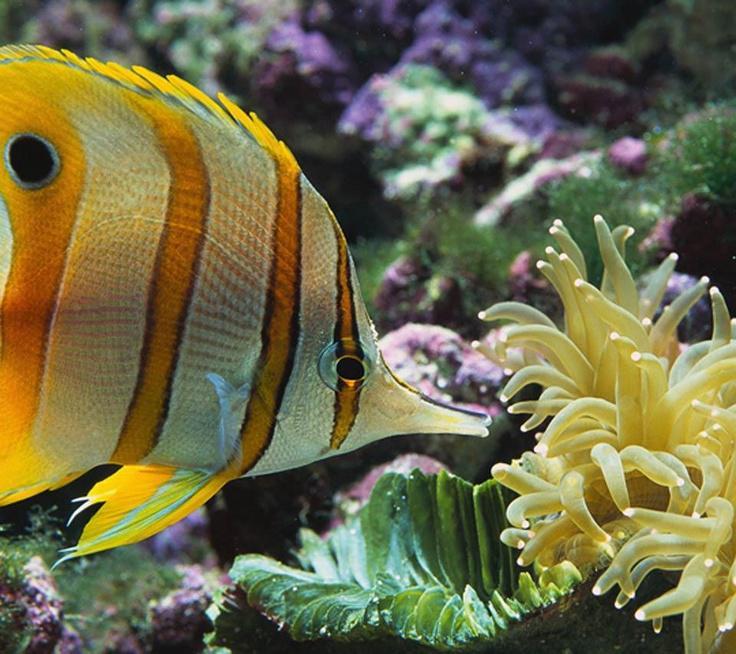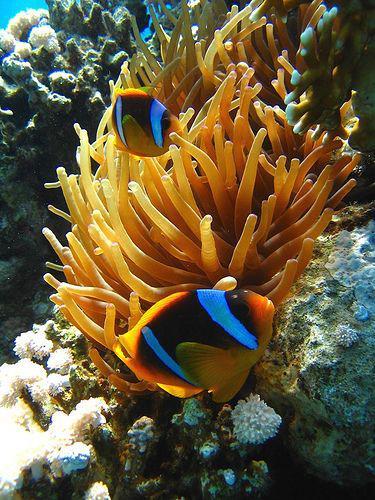The first image is the image on the left, the second image is the image on the right. Evaluate the accuracy of this statement regarding the images: "Each image includes a striped fish swimming near the tendrils of an anemone.". Is it true? Answer yes or no. Yes. The first image is the image on the left, the second image is the image on the right. For the images displayed, is the sentence "A yellow, black and white striped fish is swimming around sea plants in the image on the left." factually correct? Answer yes or no. Yes. 